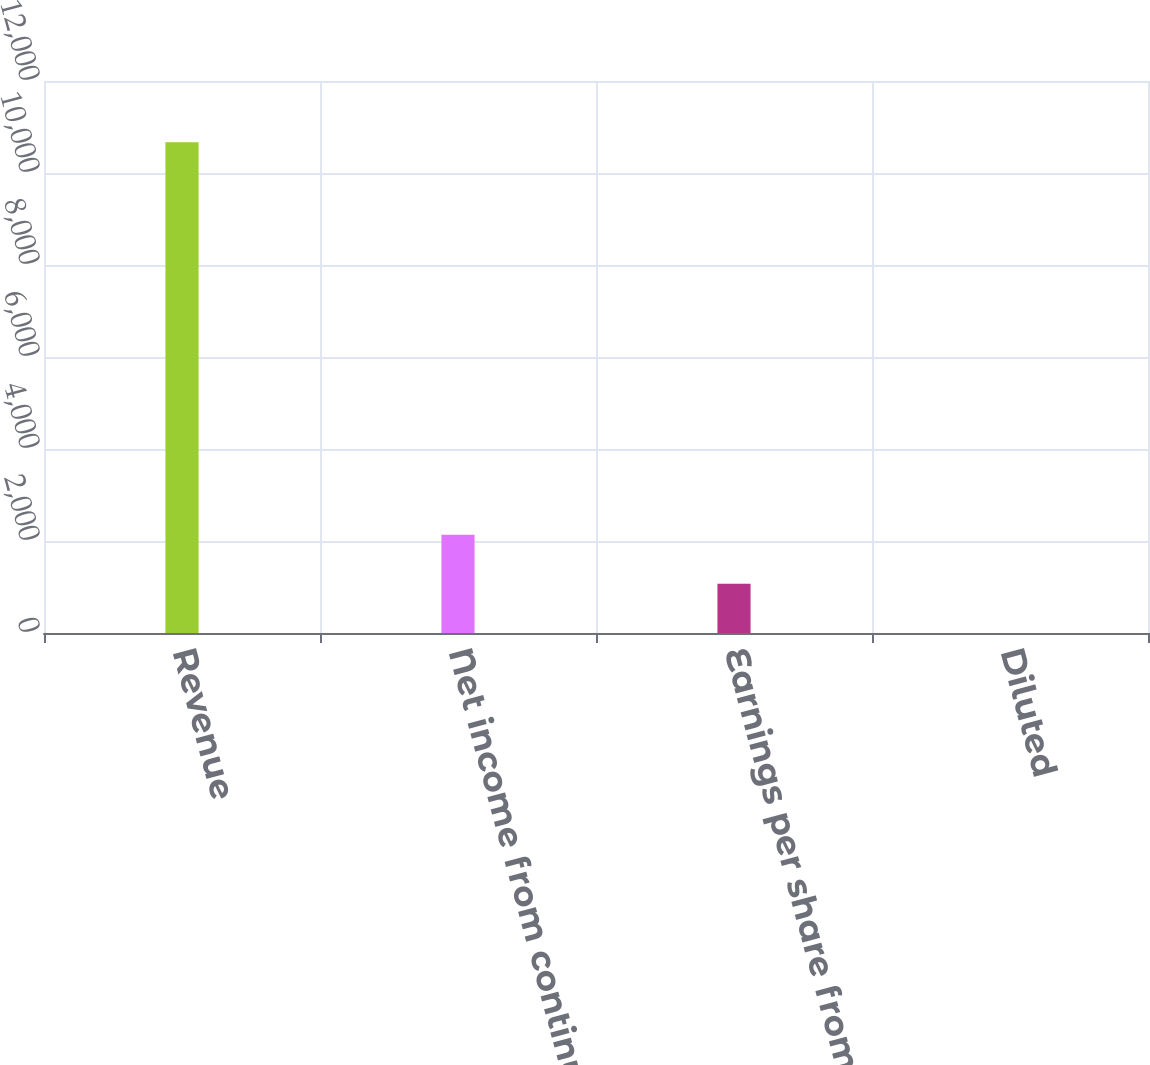Convert chart. <chart><loc_0><loc_0><loc_500><loc_500><bar_chart><fcel>Revenue<fcel>Net income from continuing<fcel>Earnings per share from<fcel>Diluted<nl><fcel>10669<fcel>2135.53<fcel>1068.84<fcel>2.15<nl></chart> 